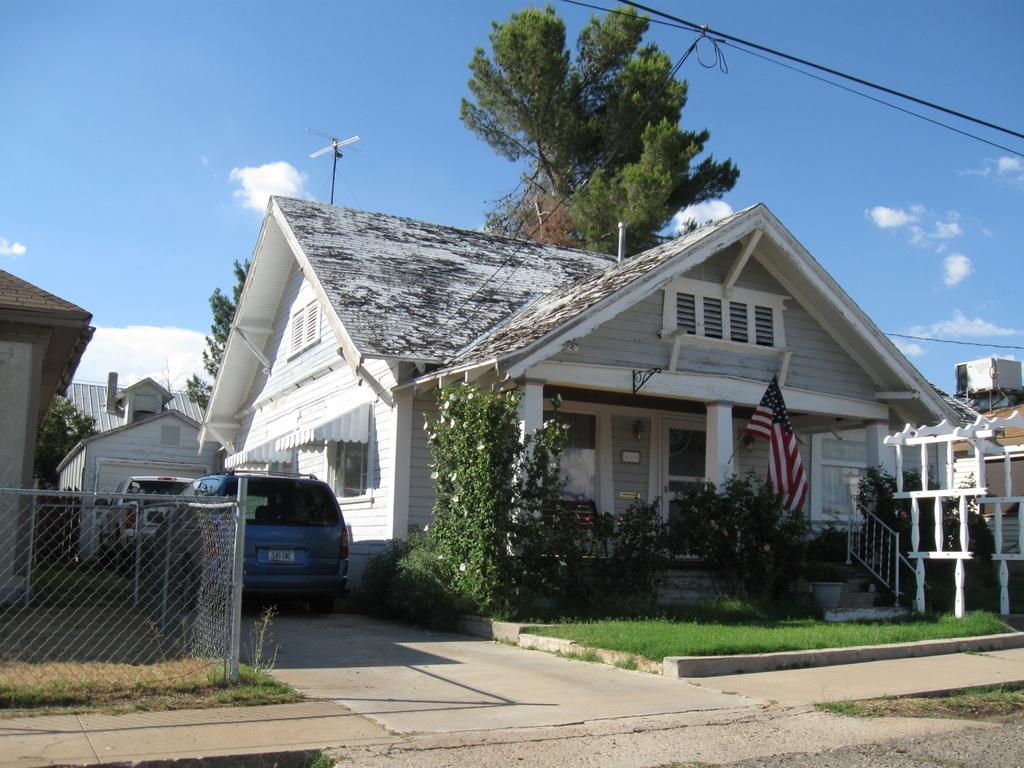In one or two sentences, can you explain what this image depicts? In this image there is the sky towards the top of the image, there are clouds in the sky, there are houses, there are trees, there is a flag, there are cars, there are plants, there are flowers, there is a fence towards the left of the image, there is grass, there is road towards the bottom of the image, there are wires towards the right of the image, there are pillars, there is a door, there are windows, there is a wall towards the left of the image. 